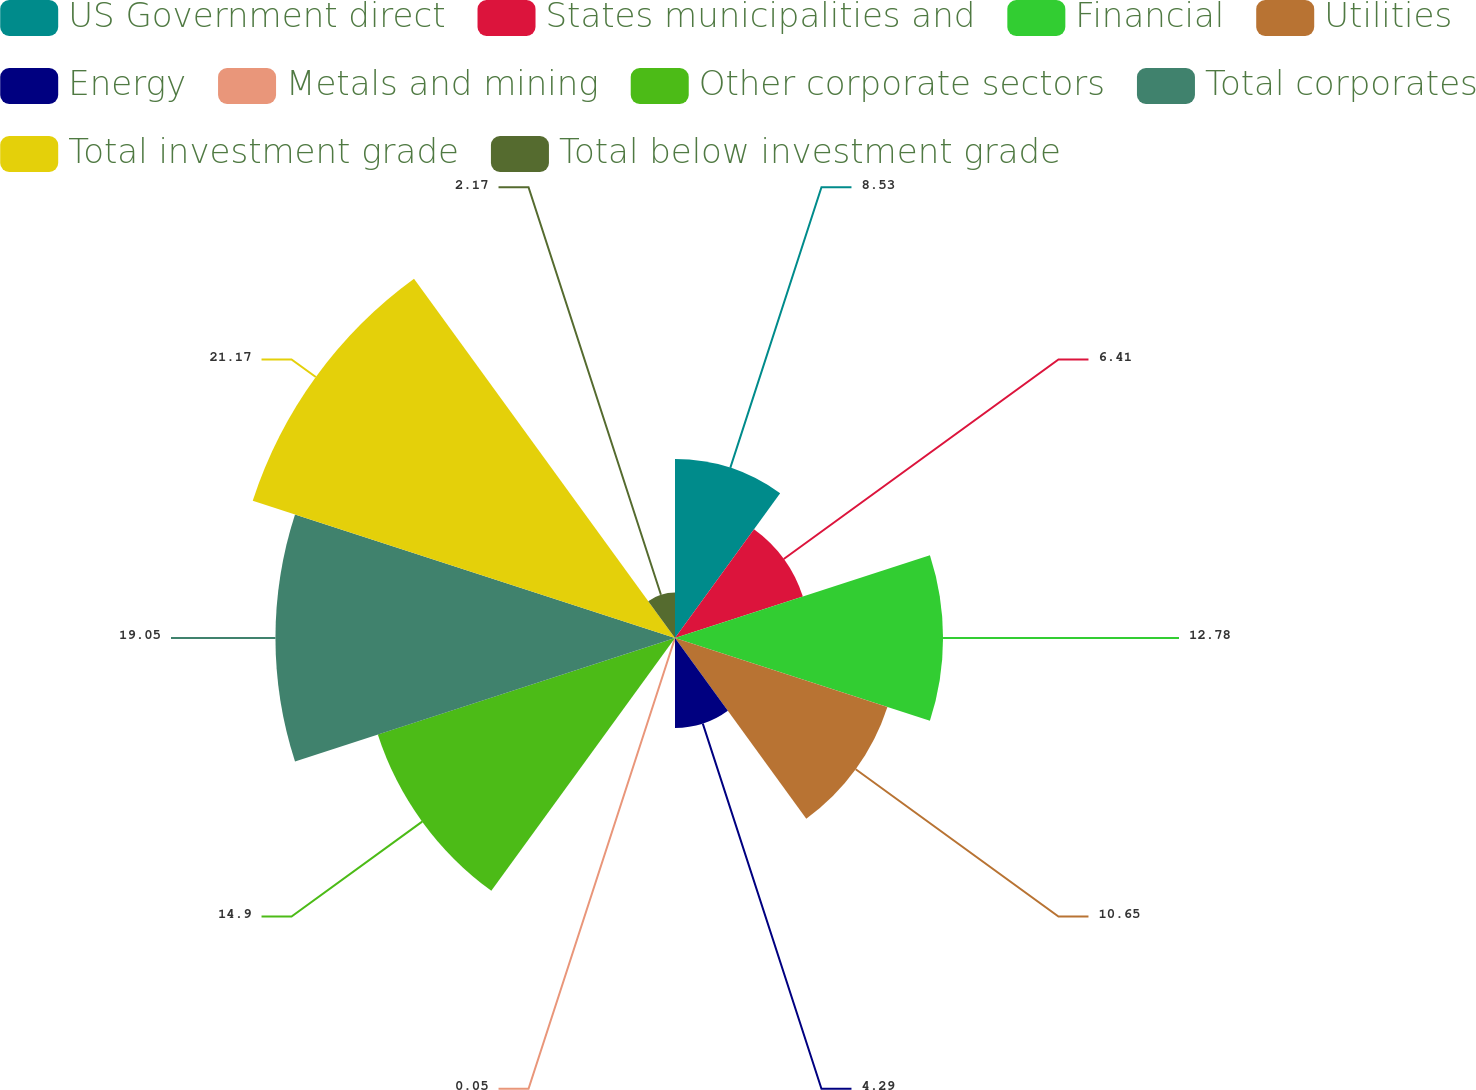Convert chart to OTSL. <chart><loc_0><loc_0><loc_500><loc_500><pie_chart><fcel>US Government direct<fcel>States municipalities and<fcel>Financial<fcel>Utilities<fcel>Energy<fcel>Metals and mining<fcel>Other corporate sectors<fcel>Total corporates<fcel>Total investment grade<fcel>Total below investment grade<nl><fcel>8.53%<fcel>6.41%<fcel>12.78%<fcel>10.65%<fcel>4.29%<fcel>0.05%<fcel>14.9%<fcel>19.05%<fcel>21.17%<fcel>2.17%<nl></chart> 